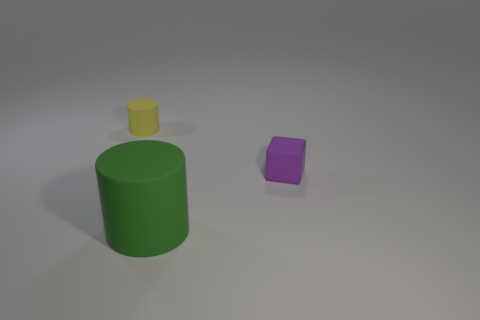Are there any other things that are the same size as the green rubber cylinder?
Your response must be concise. No. Are there any matte objects on the left side of the green cylinder?
Make the answer very short. Yes. How big is the cylinder that is behind the tiny purple matte object that is in front of the tiny matte cylinder?
Offer a terse response. Small. Are there the same number of small things behind the yellow thing and large green matte things behind the large green cylinder?
Your answer should be compact. Yes. There is a object that is behind the purple matte object; are there any matte cylinders that are right of it?
Ensure brevity in your answer.  Yes. How many big green rubber cylinders are to the left of the object that is in front of the tiny thing that is to the right of the big matte cylinder?
Provide a succinct answer. 0. Are there fewer small purple things than purple spheres?
Ensure brevity in your answer.  No. Does the small thing that is to the right of the yellow cylinder have the same shape as the small rubber object that is behind the purple matte block?
Ensure brevity in your answer.  No. What color is the matte block?
Offer a very short reply. Purple. How many rubber objects are large cyan balls or tiny yellow cylinders?
Ensure brevity in your answer.  1. 